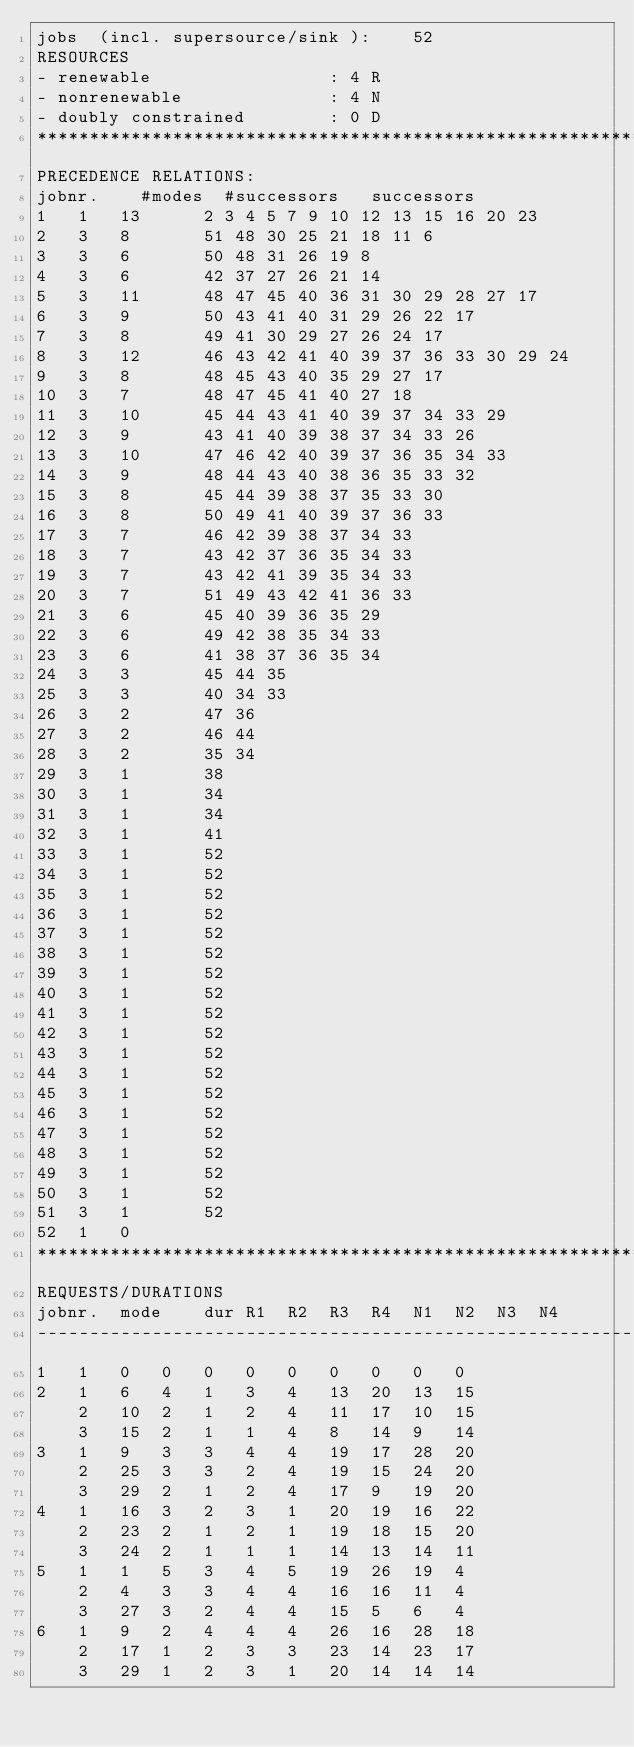Convert code to text. <code><loc_0><loc_0><loc_500><loc_500><_ObjectiveC_>jobs  (incl. supersource/sink ):	52
RESOURCES
- renewable                 : 4 R
- nonrenewable              : 4 N
- doubly constrained        : 0 D
************************************************************************
PRECEDENCE RELATIONS:
jobnr.    #modes  #successors   successors
1	1	13		2 3 4 5 7 9 10 12 13 15 16 20 23 
2	3	8		51 48 30 25 21 18 11 6 
3	3	6		50 48 31 26 19 8 
4	3	6		42 37 27 26 21 14 
5	3	11		48 47 45 40 36 31 30 29 28 27 17 
6	3	9		50 43 41 40 31 29 26 22 17 
7	3	8		49 41 30 29 27 26 24 17 
8	3	12		46 43 42 41 40 39 37 36 33 30 29 24 
9	3	8		48 45 43 40 35 29 27 17 
10	3	7		48 47 45 41 40 27 18 
11	3	10		45 44 43 41 40 39 37 34 33 29 
12	3	9		43 41 40 39 38 37 34 33 26 
13	3	10		47 46 42 40 39 37 36 35 34 33 
14	3	9		48 44 43 40 38 36 35 33 32 
15	3	8		45 44 39 38 37 35 33 30 
16	3	8		50 49 41 40 39 37 36 33 
17	3	7		46 42 39 38 37 34 33 
18	3	7		43 42 37 36 35 34 33 
19	3	7		43 42 41 39 35 34 33 
20	3	7		51 49 43 42 41 36 33 
21	3	6		45 40 39 36 35 29 
22	3	6		49 42 38 35 34 33 
23	3	6		41 38 37 36 35 34 
24	3	3		45 44 35 
25	3	3		40 34 33 
26	3	2		47 36 
27	3	2		46 44 
28	3	2		35 34 
29	3	1		38 
30	3	1		34 
31	3	1		34 
32	3	1		41 
33	3	1		52 
34	3	1		52 
35	3	1		52 
36	3	1		52 
37	3	1		52 
38	3	1		52 
39	3	1		52 
40	3	1		52 
41	3	1		52 
42	3	1		52 
43	3	1		52 
44	3	1		52 
45	3	1		52 
46	3	1		52 
47	3	1		52 
48	3	1		52 
49	3	1		52 
50	3	1		52 
51	3	1		52 
52	1	0		
************************************************************************
REQUESTS/DURATIONS
jobnr.	mode	dur	R1	R2	R3	R4	N1	N2	N3	N4	
------------------------------------------------------------------------
1	1	0	0	0	0	0	0	0	0	0	
2	1	6	4	1	3	4	13	20	13	15	
	2	10	2	1	2	4	11	17	10	15	
	3	15	2	1	1	4	8	14	9	14	
3	1	9	3	3	4	4	19	17	28	20	
	2	25	3	3	2	4	19	15	24	20	
	3	29	2	1	2	4	17	9	19	20	
4	1	16	3	2	3	1	20	19	16	22	
	2	23	2	1	2	1	19	18	15	20	
	3	24	2	1	1	1	14	13	14	11	
5	1	1	5	3	4	5	19	26	19	4	
	2	4	3	3	4	4	16	16	11	4	
	3	27	3	2	4	4	15	5	6	4	
6	1	9	2	4	4	4	26	16	28	18	
	2	17	1	2	3	3	23	14	23	17	
	3	29	1	2	3	1	20	14	14	14	</code> 